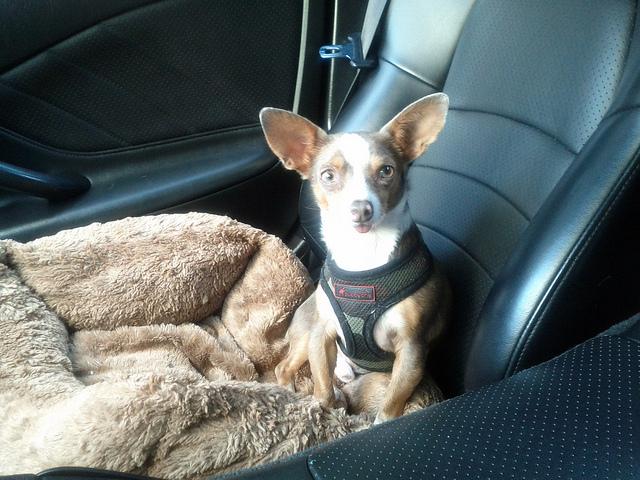What is the dog sitting on?
Write a very short answer. Blanket. What animal is pictured?
Give a very brief answer. Dog. Is this a large dog?
Quick response, please. No. 